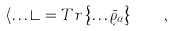<formula> <loc_0><loc_0><loc_500><loc_500>\left \langle \dots \right \rangle = T r \left \{ \dots \bar { \varrho } _ { \alpha } \right \} \quad ,</formula> 